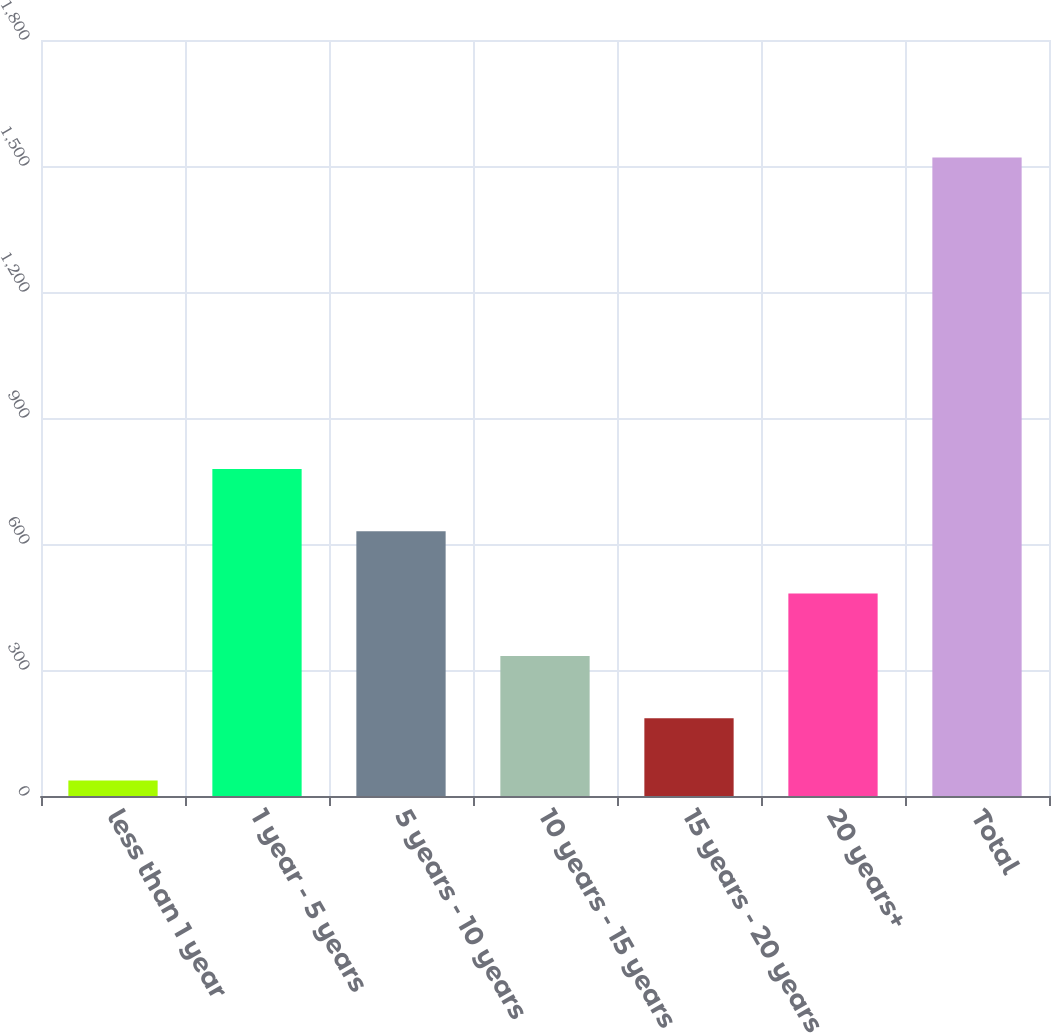Convert chart to OTSL. <chart><loc_0><loc_0><loc_500><loc_500><bar_chart><fcel>less than 1 year<fcel>1 year - 5 years<fcel>5 years - 10 years<fcel>10 years - 15 years<fcel>15 years - 20 years<fcel>20 years+<fcel>Total<nl><fcel>37<fcel>778.5<fcel>630.2<fcel>333.6<fcel>185.3<fcel>481.9<fcel>1520<nl></chart> 